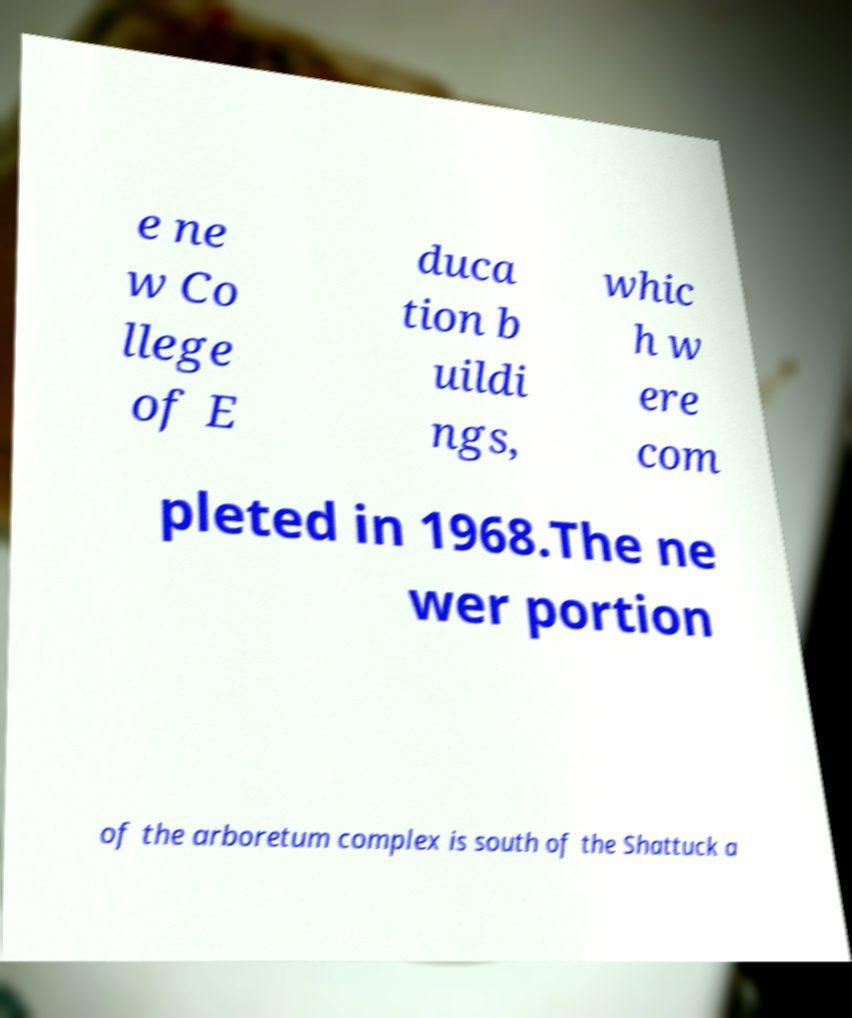There's text embedded in this image that I need extracted. Can you transcribe it verbatim? e ne w Co llege of E duca tion b uildi ngs, whic h w ere com pleted in 1968.The ne wer portion of the arboretum complex is south of the Shattuck a 